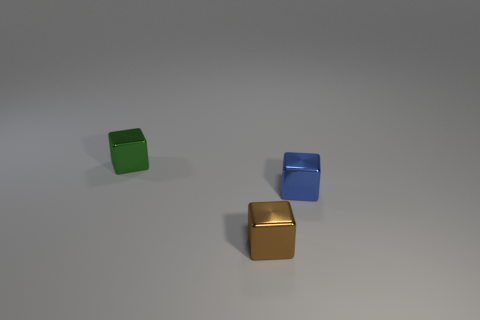There is a block that is on the right side of the shiny thing that is in front of the tiny blue object; are there any small brown blocks to the right of it?
Your answer should be very brief. No. Are there any green rubber spheres of the same size as the green metallic object?
Keep it short and to the point. No. There is a small metallic object behind the shiny object to the right of the thing in front of the blue block; what is its color?
Your response must be concise. Green. There is a tiny block that is to the right of the block in front of the blue object; what is its color?
Your answer should be very brief. Blue. Are there more green things that are left of the brown metal cube than tiny blue metal things that are behind the green metallic block?
Your response must be concise. Yes. Is the tiny block behind the blue metallic cube made of the same material as the cube on the right side of the brown metal object?
Your response must be concise. Yes. There is a brown cube; are there any tiny things to the left of it?
Provide a succinct answer. Yes. What number of blue objects are tiny matte cylinders or metallic blocks?
Your answer should be very brief. 1. Do the green object and the cube in front of the blue object have the same material?
Your answer should be compact. Yes. There is a object that is on the right side of the brown shiny object; does it have the same size as the shiny object left of the brown metal cube?
Your answer should be compact. Yes. 